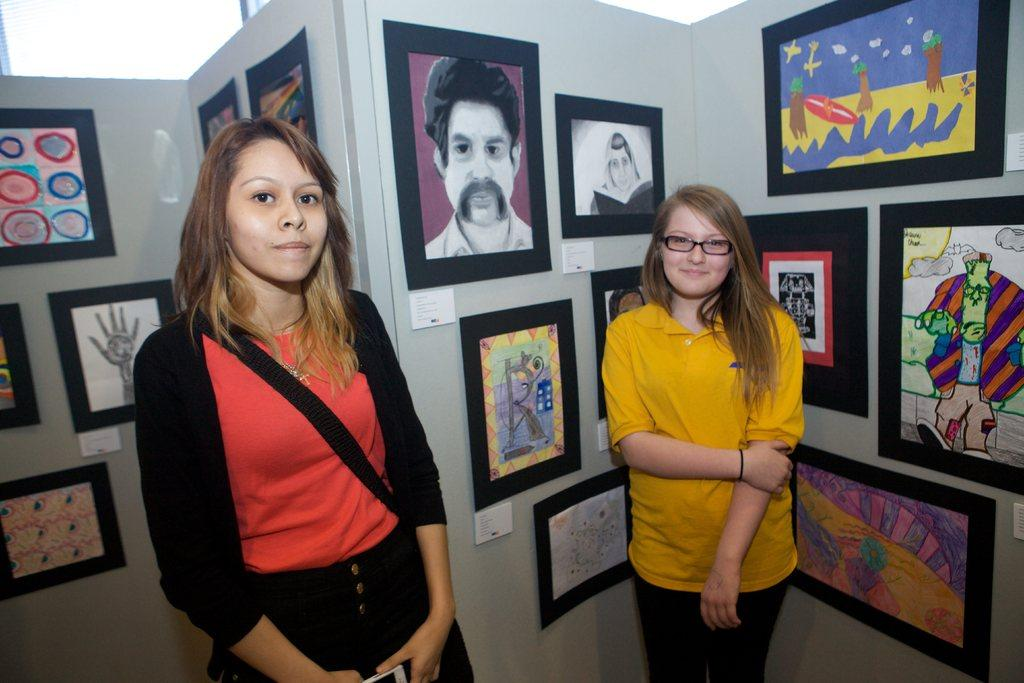Who is present in the image? There are women in the image. Where are the women located in the image? The women are standing in the center of the image. What expression do the women have? The women are smiling. What can be seen in the background of the image? There are frames on the wall in the background of the image. What type of pies are the women baking in the image? There is no indication of pies or baking in the image; the women are simply standing and smiling. 